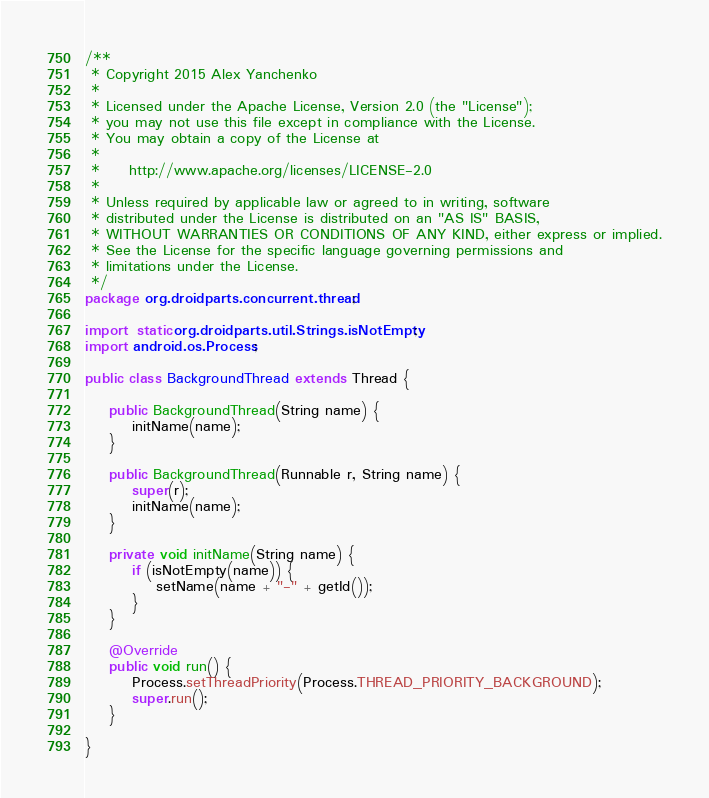<code> <loc_0><loc_0><loc_500><loc_500><_Java_>/**
 * Copyright 2015 Alex Yanchenko
 * 
 * Licensed under the Apache License, Version 2.0 (the "License");
 * you may not use this file except in compliance with the License.
 * You may obtain a copy of the License at
 *  
 *     http://www.apache.org/licenses/LICENSE-2.0
 * 
 * Unless required by applicable law or agreed to in writing, software
 * distributed under the License is distributed on an "AS IS" BASIS,
 * WITHOUT WARRANTIES OR CONDITIONS OF ANY KIND, either express or implied.
 * See the License for the specific language governing permissions and
 * limitations under the License. 
 */
package org.droidparts.concurrent.thread;

import static org.droidparts.util.Strings.isNotEmpty;
import android.os.Process;

public class BackgroundThread extends Thread {

	public BackgroundThread(String name) {
		initName(name);
	}

	public BackgroundThread(Runnable r, String name) {
		super(r);
		initName(name);
	}

	private void initName(String name) {
		if (isNotEmpty(name)) {
			setName(name + "-" + getId());
		}
	}

	@Override
	public void run() {
		Process.setThreadPriority(Process.THREAD_PRIORITY_BACKGROUND);
		super.run();
	}

}
</code> 